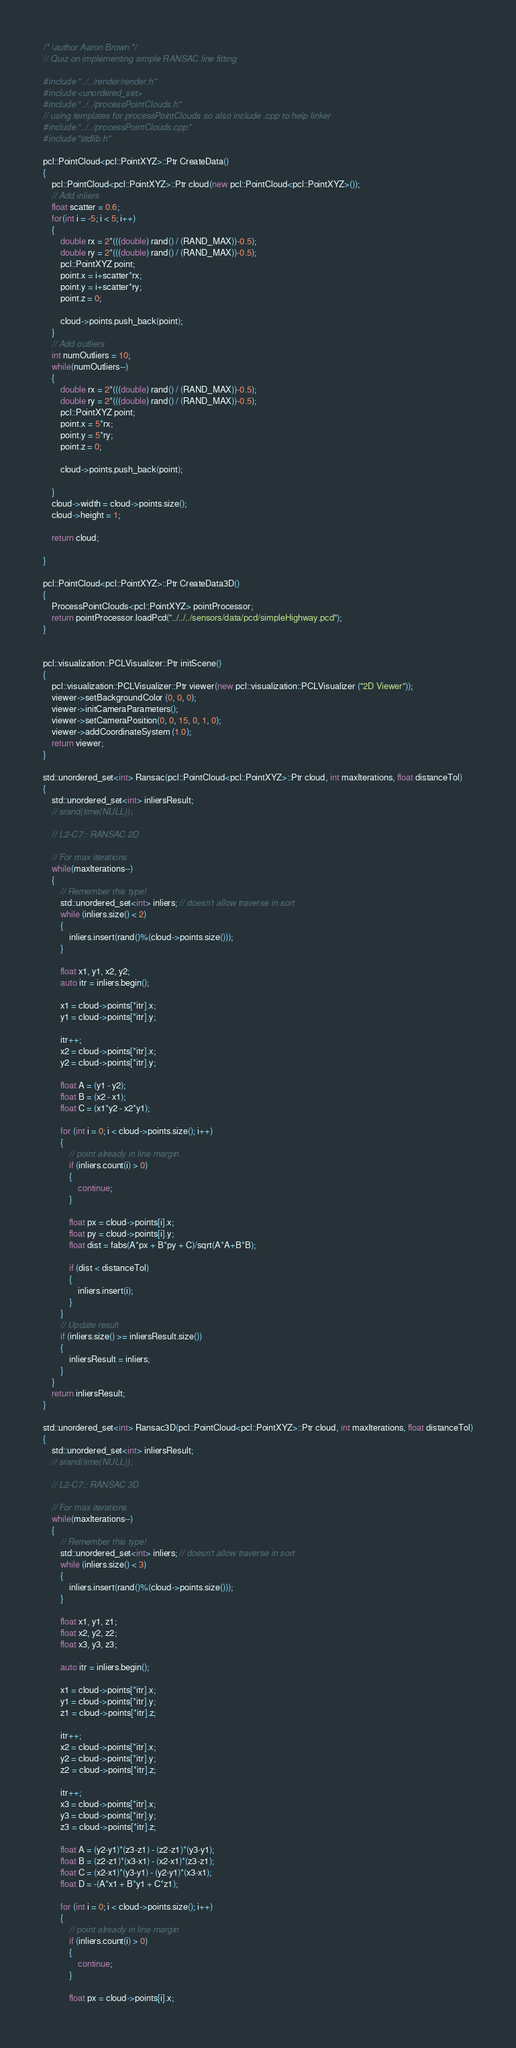Convert code to text. <code><loc_0><loc_0><loc_500><loc_500><_C++_>/* \author Aaron Brown */
// Quiz on implementing simple RANSAC line fitting

#include "../../render/render.h"
#include <unordered_set>
#include "../../processPointClouds.h"
// using templates for processPointClouds so also include .cpp to help linker
#include "../../processPointClouds.cpp"
#include "stdlib.h"

pcl::PointCloud<pcl::PointXYZ>::Ptr CreateData()
{
	pcl::PointCloud<pcl::PointXYZ>::Ptr cloud(new pcl::PointCloud<pcl::PointXYZ>());
  	// Add inliers
  	float scatter = 0.6;
  	for(int i = -5; i < 5; i++)
  	{
  		double rx = 2*(((double) rand() / (RAND_MAX))-0.5);
  		double ry = 2*(((double) rand() / (RAND_MAX))-0.5);
  		pcl::PointXYZ point;
  		point.x = i+scatter*rx;
  		point.y = i+scatter*ry;
  		point.z = 0;

  		cloud->points.push_back(point);
  	}
  	// Add outliers
  	int numOutliers = 10;
  	while(numOutliers--)
  	{
  		double rx = 2*(((double) rand() / (RAND_MAX))-0.5);
  		double ry = 2*(((double) rand() / (RAND_MAX))-0.5);
  		pcl::PointXYZ point;
  		point.x = 5*rx;
  		point.y = 5*ry;
  		point.z = 0;

  		cloud->points.push_back(point);

  	}
  	cloud->width = cloud->points.size();
  	cloud->height = 1;

  	return cloud;

}

pcl::PointCloud<pcl::PointXYZ>::Ptr CreateData3D()
{
	ProcessPointClouds<pcl::PointXYZ> pointProcessor;
	return pointProcessor.loadPcd("../../../sensors/data/pcd/simpleHighway.pcd");
}


pcl::visualization::PCLVisualizer::Ptr initScene()
{
	pcl::visualization::PCLVisualizer::Ptr viewer(new pcl::visualization::PCLVisualizer ("2D Viewer"));
	viewer->setBackgroundColor (0, 0, 0);
  	viewer->initCameraParameters();
  	viewer->setCameraPosition(0, 0, 15, 0, 1, 0);
  	viewer->addCoordinateSystem (1.0);
  	return viewer;
}

std::unordered_set<int> Ransac(pcl::PointCloud<pcl::PointXYZ>::Ptr cloud, int maxIterations, float distanceTol)
{
	std::unordered_set<int> inliersResult;
	// srand(time(NULL));
	
	// L2-C7:: RANSAC 2D

	// For max iterations 
	while(maxIterations--)
	{	
		// Remember this type!
		std::unordered_set<int> inliers; // doesn't allow traverse in sort
		while (inliers.size() < 2)
		{
			inliers.insert(rand()%(cloud->points.size()));
		}

		float x1, y1, x2, y2; 
		auto itr = inliers.begin();

		x1 = cloud->points[*itr].x;
		y1 = cloud->points[*itr].y;

		itr++;
		x2 = cloud->points[*itr].x;
		y2 = cloud->points[*itr].y;

		float A = (y1 - y2);
		float B = (x2 - x1);
		float C = (x1*y2 - x2*y1);

		for (int i = 0; i < cloud->points.size(); i++)
		{
			// point already in line margin
			if (inliers.count(i) > 0)
			{
				continue;
			}

			float px = cloud->points[i].x;
			float py = cloud->points[i].y;
			float dist = fabs(A*px + B*py + C)/sqrt(A*A+B*B);

			if (dist < distanceTol)
			{
				inliers.insert(i);
			}
		}
		// Update result
		if (inliers.size() >= inliersResult.size())
		{
			inliersResult = inliers;
		}
	}
	return inliersResult;
}

std::unordered_set<int> Ransac3D(pcl::PointCloud<pcl::PointXYZ>::Ptr cloud, int maxIterations, float distanceTol)
{
	std::unordered_set<int> inliersResult;
	// srand(time(NULL));
	
	// L2-C7:: RANSAC 3D

	// For max iterations 
	while(maxIterations--)
	{	
		// Remember this type!
		std::unordered_set<int> inliers; // doesn't allow traverse in sort
		while (inliers.size() < 3)
		{
			inliers.insert(rand()%(cloud->points.size()));
		}

		float x1, y1, z1;
		float x2, y2, z2;
		float x3, y3, z3;

		auto itr = inliers.begin();

		x1 = cloud->points[*itr].x;
		y1 = cloud->points[*itr].y;
		z1 = cloud->points[*itr].z;

		itr++;
		x2 = cloud->points[*itr].x;
		y2 = cloud->points[*itr].y;
		z2 = cloud->points[*itr].z;

		itr++;
		x3 = cloud->points[*itr].x;
		y3 = cloud->points[*itr].y;
		z3 = cloud->points[*itr].z;

		float A = (y2-y1)*(z3-z1) - (z2-z1)*(y3-y1);
		float B = (z2-z1)*(x3-x1) - (x2-x1)*(z3-z1);
		float C = (x2-x1)*(y3-y1) - (y2-y1)*(x3-x1);
		float D = -(A*x1 + B*y1 + C*z1);

		for (int i = 0; i < cloud->points.size(); i++)
		{
			// point already in line margin
			if (inliers.count(i) > 0)
			{
				continue;
			}

			float px = cloud->points[i].x;</code> 